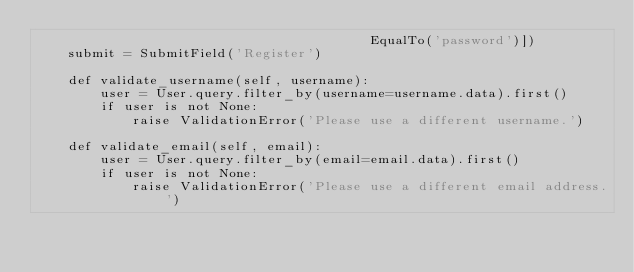<code> <loc_0><loc_0><loc_500><loc_500><_Python_>                                          EqualTo('password')])
    submit = SubmitField('Register')

    def validate_username(self, username):
        user = User.query.filter_by(username=username.data).first()
        if user is not None:
            raise ValidationError('Please use a different username.')

    def validate_email(self, email):
        user = User.query.filter_by(email=email.data).first()
        if user is not None:
            raise ValidationError('Please use a different email address.')
</code> 